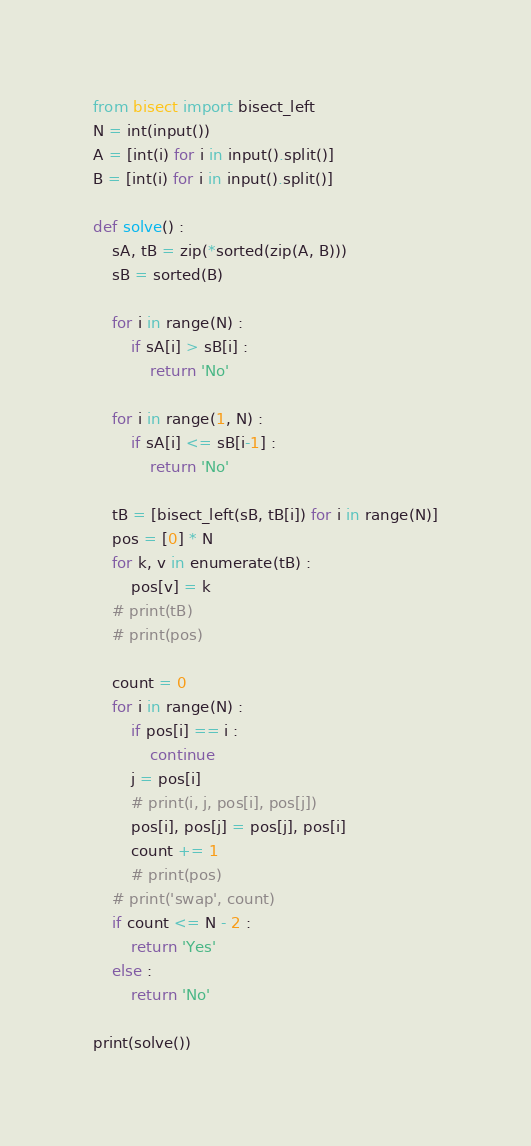Convert code to text. <code><loc_0><loc_0><loc_500><loc_500><_Python_>from bisect import bisect_left
N = int(input())
A = [int(i) for i in input().split()]
B = [int(i) for i in input().split()]

def solve() :
    sA, tB = zip(*sorted(zip(A, B)))
    sB = sorted(B)
    
    for i in range(N) :
        if sA[i] > sB[i] :
            return 'No'
            
    for i in range(1, N) :
        if sA[i] <= sB[i-1] :
            return 'No'
    
    tB = [bisect_left(sB, tB[i]) for i in range(N)]
    pos = [0] * N
    for k, v in enumerate(tB) :
        pos[v] = k
    # print(tB)
    # print(pos)
    
    count = 0
    for i in range(N) :
        if pos[i] == i :
            continue
        j = pos[i]
        # print(i, j, pos[i], pos[j])
        pos[i], pos[j] = pos[j], pos[i]
        count += 1
        # print(pos)
    # print('swap', count)
    if count <= N - 2 :
        return 'Yes'
    else :
        return 'No'
    
print(solve())</code> 